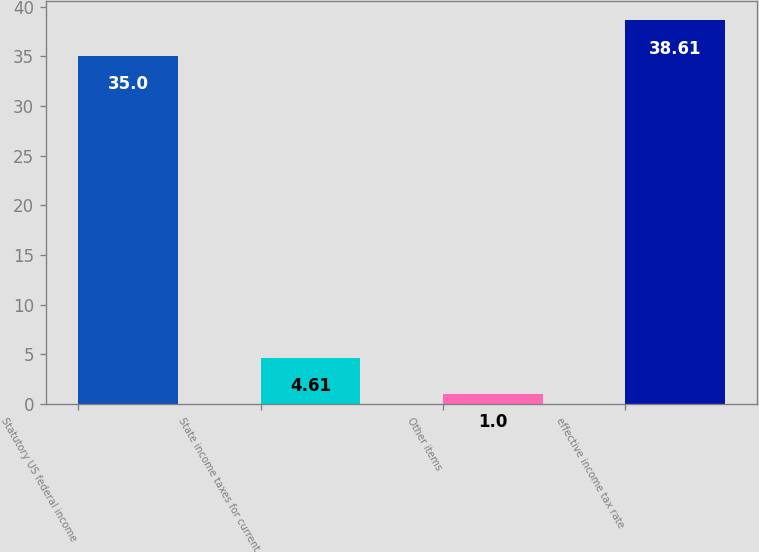Convert chart. <chart><loc_0><loc_0><loc_500><loc_500><bar_chart><fcel>Statutory US federal income<fcel>State income taxes for current<fcel>Other items<fcel>effective income tax rate<nl><fcel>35<fcel>4.61<fcel>1<fcel>38.61<nl></chart> 